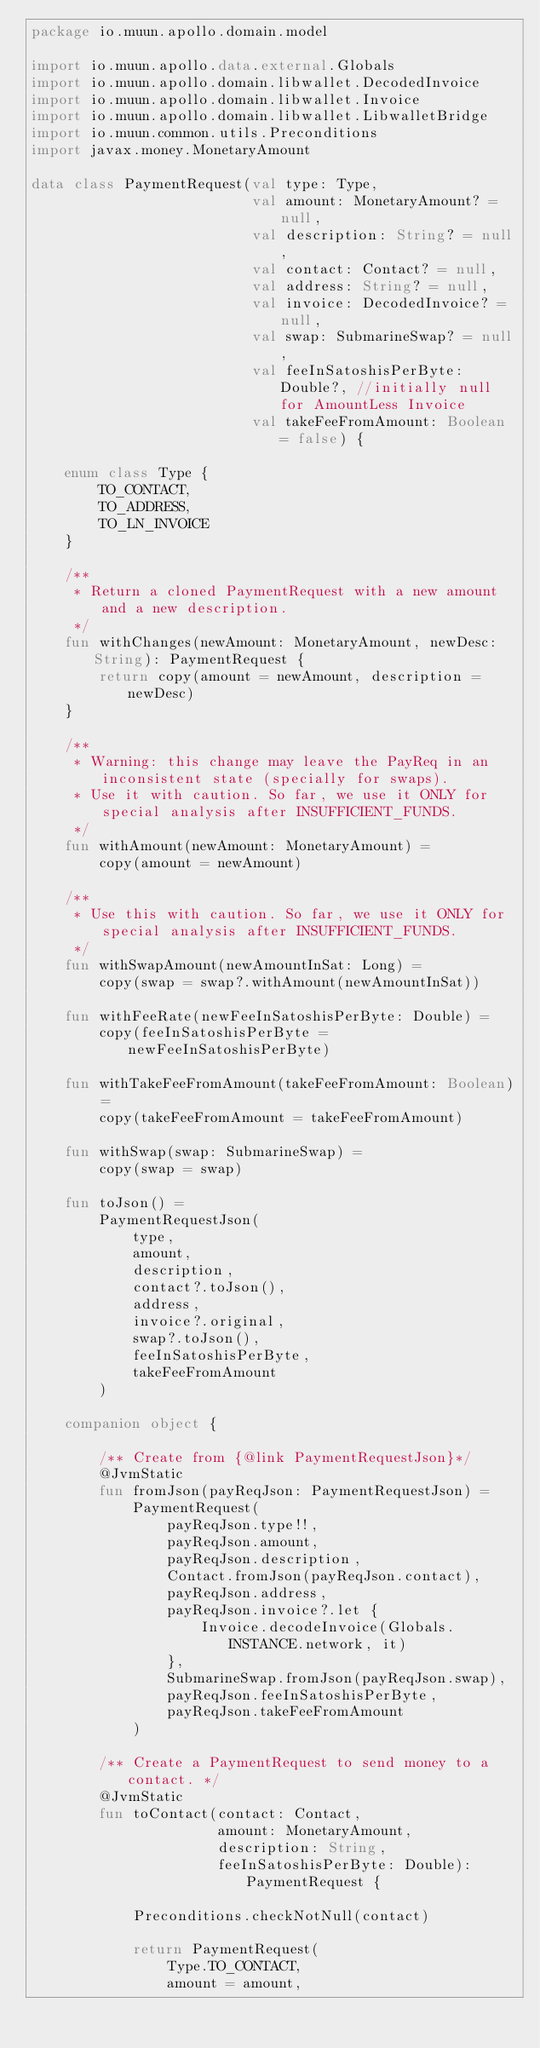Convert code to text. <code><loc_0><loc_0><loc_500><loc_500><_Kotlin_>package io.muun.apollo.domain.model

import io.muun.apollo.data.external.Globals
import io.muun.apollo.domain.libwallet.DecodedInvoice
import io.muun.apollo.domain.libwallet.Invoice
import io.muun.apollo.domain.libwallet.LibwalletBridge
import io.muun.common.utils.Preconditions
import javax.money.MonetaryAmount

data class PaymentRequest(val type: Type,
                          val amount: MonetaryAmount? = null,
                          val description: String? = null,
                          val contact: Contact? = null,
                          val address: String? = null,
                          val invoice: DecodedInvoice? = null,
                          val swap: SubmarineSwap? = null,
                          val feeInSatoshisPerByte: Double?, //initially null for AmountLess Invoice
                          val takeFeeFromAmount: Boolean = false) {

    enum class Type {
        TO_CONTACT,
        TO_ADDRESS,
        TO_LN_INVOICE
    }

    /**
     * Return a cloned PaymentRequest with a new amount and a new description.
     */
    fun withChanges(newAmount: MonetaryAmount, newDesc: String): PaymentRequest {
        return copy(amount = newAmount, description = newDesc)
    }

    /**
     * Warning: this change may leave the PayReq in an inconsistent state (specially for swaps).
     * Use it with caution. So far, we use it ONLY for special analysis after INSUFFICIENT_FUNDS.
     */
    fun withAmount(newAmount: MonetaryAmount) =
        copy(amount = newAmount)

    /**
     * Use this with caution. So far, we use it ONLY for special analysis after INSUFFICIENT_FUNDS.
     */
    fun withSwapAmount(newAmountInSat: Long) =
        copy(swap = swap?.withAmount(newAmountInSat))

    fun withFeeRate(newFeeInSatoshisPerByte: Double) =
        copy(feeInSatoshisPerByte = newFeeInSatoshisPerByte)

    fun withTakeFeeFromAmount(takeFeeFromAmount: Boolean) =
        copy(takeFeeFromAmount = takeFeeFromAmount)

    fun withSwap(swap: SubmarineSwap) =
        copy(swap = swap)

    fun toJson() =
        PaymentRequestJson(
            type,
            amount,
            description,
            contact?.toJson(),
            address,
            invoice?.original,
            swap?.toJson(),
            feeInSatoshisPerByte,
            takeFeeFromAmount
        )

    companion object {

        /** Create from {@link PaymentRequestJson}*/
        @JvmStatic
        fun fromJson(payReqJson: PaymentRequestJson) =
            PaymentRequest(
                payReqJson.type!!,
                payReqJson.amount,
                payReqJson.description,
                Contact.fromJson(payReqJson.contact),
                payReqJson.address,
                payReqJson.invoice?.let {
                    Invoice.decodeInvoice(Globals.INSTANCE.network, it)
                },
                SubmarineSwap.fromJson(payReqJson.swap),
                payReqJson.feeInSatoshisPerByte,
                payReqJson.takeFeeFromAmount
            )

        /** Create a PaymentRequest to send money to a contact. */
        @JvmStatic
        fun toContact(contact: Contact,
                      amount: MonetaryAmount,
                      description: String,
                      feeInSatoshisPerByte: Double): PaymentRequest {

            Preconditions.checkNotNull(contact)

            return PaymentRequest(
                Type.TO_CONTACT,
                amount = amount,</code> 